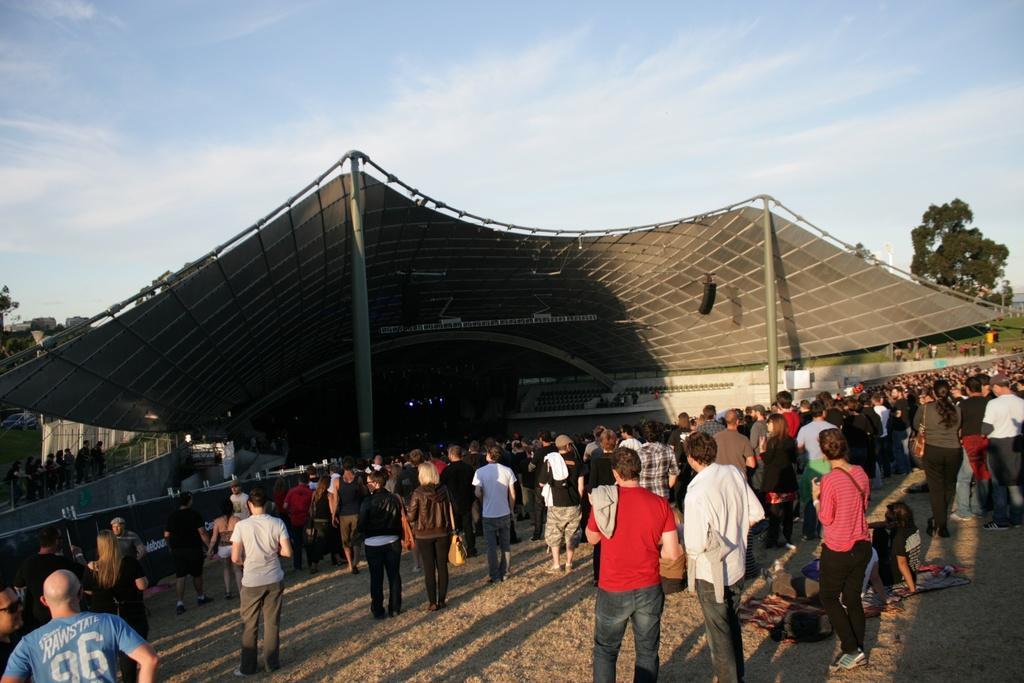Please provide a concise description of this image. This is an outside view. At the bottom of the image I can see a crowd of people standing on the ground. In the middle of the image there is a shed. On the right and left side of the image there are few trees. At the top of the image I can see the sky and clouds. 